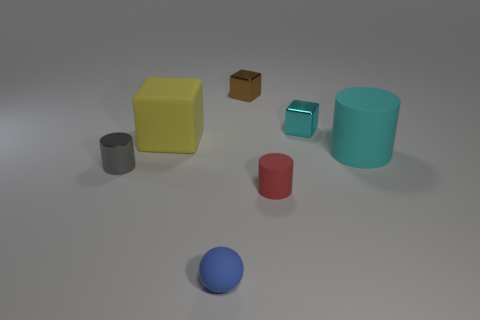Add 1 tiny yellow rubber objects. How many objects exist? 8 Subtract all cylinders. How many objects are left? 4 Add 5 red matte things. How many red matte things are left? 6 Add 5 big cylinders. How many big cylinders exist? 6 Subtract 1 red cylinders. How many objects are left? 6 Subtract all cyan cylinders. Subtract all large green spheres. How many objects are left? 6 